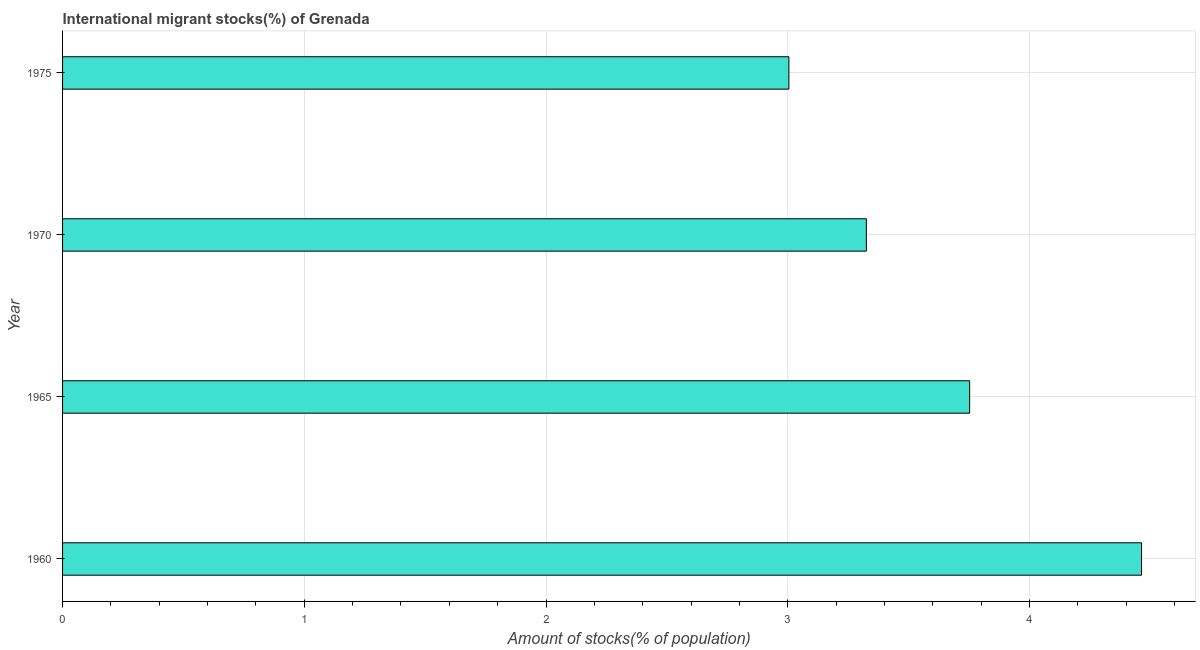Does the graph contain any zero values?
Keep it short and to the point. No. Does the graph contain grids?
Give a very brief answer. Yes. What is the title of the graph?
Offer a very short reply. International migrant stocks(%) of Grenada. What is the label or title of the X-axis?
Offer a terse response. Amount of stocks(% of population). What is the number of international migrant stocks in 1960?
Your answer should be compact. 4.46. Across all years, what is the maximum number of international migrant stocks?
Make the answer very short. 4.46. Across all years, what is the minimum number of international migrant stocks?
Ensure brevity in your answer.  3. In which year was the number of international migrant stocks minimum?
Your response must be concise. 1975. What is the sum of the number of international migrant stocks?
Your answer should be compact. 14.55. What is the difference between the number of international migrant stocks in 1960 and 1975?
Give a very brief answer. 1.46. What is the average number of international migrant stocks per year?
Give a very brief answer. 3.64. What is the median number of international migrant stocks?
Give a very brief answer. 3.54. Do a majority of the years between 1965 and 1970 (inclusive) have number of international migrant stocks greater than 2.6 %?
Your answer should be very brief. Yes. What is the ratio of the number of international migrant stocks in 1960 to that in 1965?
Your answer should be compact. 1.19. Is the difference between the number of international migrant stocks in 1965 and 1975 greater than the difference between any two years?
Make the answer very short. No. What is the difference between the highest and the second highest number of international migrant stocks?
Ensure brevity in your answer.  0.71. Is the sum of the number of international migrant stocks in 1965 and 1970 greater than the maximum number of international migrant stocks across all years?
Provide a short and direct response. Yes. What is the difference between the highest and the lowest number of international migrant stocks?
Provide a short and direct response. 1.46. In how many years, is the number of international migrant stocks greater than the average number of international migrant stocks taken over all years?
Ensure brevity in your answer.  2. How many bars are there?
Provide a succinct answer. 4. Are all the bars in the graph horizontal?
Give a very brief answer. Yes. What is the difference between two consecutive major ticks on the X-axis?
Provide a succinct answer. 1. What is the Amount of stocks(% of population) of 1960?
Provide a short and direct response. 4.46. What is the Amount of stocks(% of population) in 1965?
Keep it short and to the point. 3.75. What is the Amount of stocks(% of population) of 1970?
Provide a succinct answer. 3.33. What is the Amount of stocks(% of population) of 1975?
Your response must be concise. 3. What is the difference between the Amount of stocks(% of population) in 1960 and 1965?
Offer a very short reply. 0.71. What is the difference between the Amount of stocks(% of population) in 1960 and 1970?
Offer a terse response. 1.14. What is the difference between the Amount of stocks(% of population) in 1960 and 1975?
Offer a terse response. 1.46. What is the difference between the Amount of stocks(% of population) in 1965 and 1970?
Provide a succinct answer. 0.43. What is the difference between the Amount of stocks(% of population) in 1965 and 1975?
Provide a succinct answer. 0.75. What is the difference between the Amount of stocks(% of population) in 1970 and 1975?
Offer a very short reply. 0.32. What is the ratio of the Amount of stocks(% of population) in 1960 to that in 1965?
Your answer should be very brief. 1.19. What is the ratio of the Amount of stocks(% of population) in 1960 to that in 1970?
Ensure brevity in your answer.  1.34. What is the ratio of the Amount of stocks(% of population) in 1960 to that in 1975?
Provide a succinct answer. 1.49. What is the ratio of the Amount of stocks(% of population) in 1965 to that in 1970?
Your response must be concise. 1.13. What is the ratio of the Amount of stocks(% of population) in 1965 to that in 1975?
Provide a succinct answer. 1.25. What is the ratio of the Amount of stocks(% of population) in 1970 to that in 1975?
Your answer should be very brief. 1.11. 